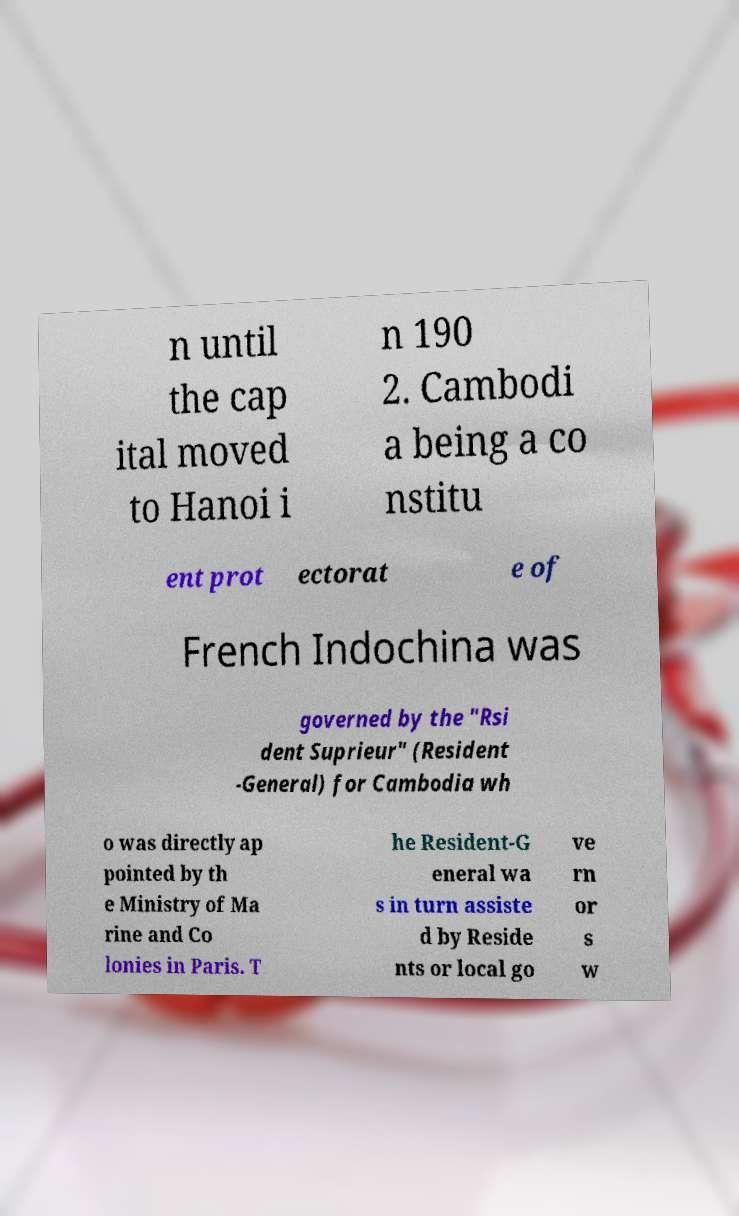Can you accurately transcribe the text from the provided image for me? n until the cap ital moved to Hanoi i n 190 2. Cambodi a being a co nstitu ent prot ectorat e of French Indochina was governed by the "Rsi dent Suprieur" (Resident -General) for Cambodia wh o was directly ap pointed by th e Ministry of Ma rine and Co lonies in Paris. T he Resident-G eneral wa s in turn assiste d by Reside nts or local go ve rn or s w 